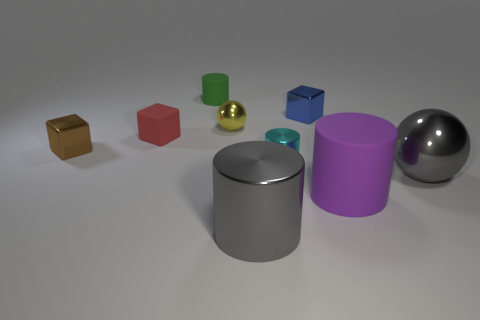Subtract all small cyan cylinders. How many cylinders are left? 3 Add 1 brown shiny cylinders. How many objects exist? 10 Subtract all blue cubes. How many cubes are left? 2 Add 4 big matte cylinders. How many big matte cylinders exist? 5 Subtract 0 blue cylinders. How many objects are left? 9 Subtract all balls. How many objects are left? 7 Subtract 2 balls. How many balls are left? 0 Subtract all green balls. Subtract all yellow blocks. How many balls are left? 2 Subtract all blue cylinders. How many gray spheres are left? 1 Subtract all green things. Subtract all tiny green objects. How many objects are left? 7 